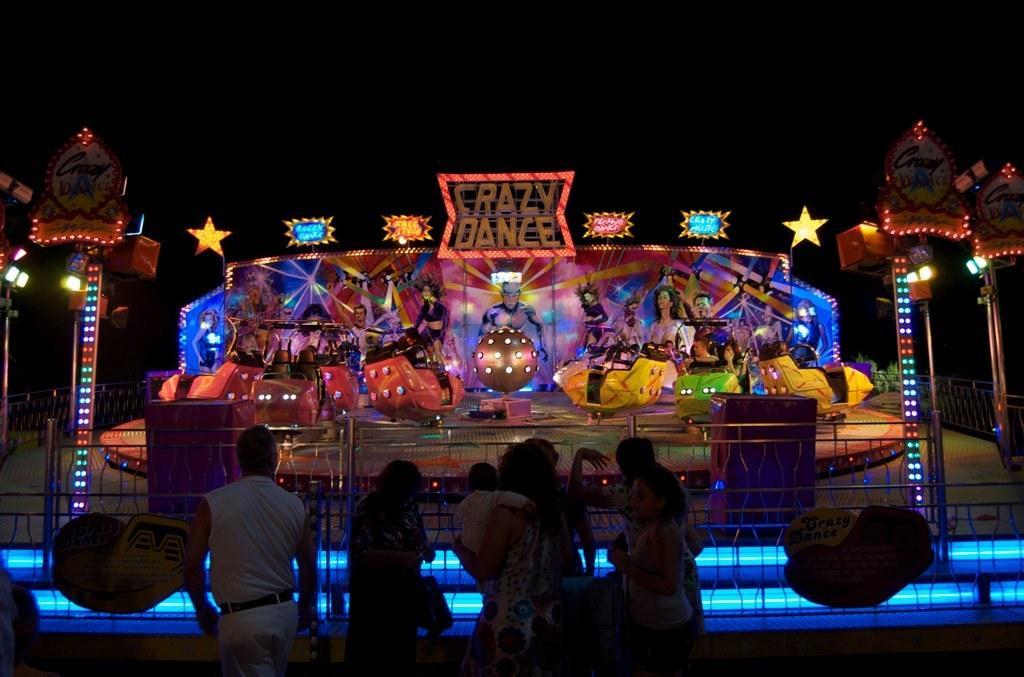Describe this image in one or two sentences. In this image in the front there are persons standing and walking. In the center there is a fence and on the fence there are posters with some text written on it. In the background there are persons in the rides and there is a board with some text written on it and there are images and there are lights and there are objects which are green in colour. 